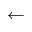<formula> <loc_0><loc_0><loc_500><loc_500>\leftarrow</formula> 